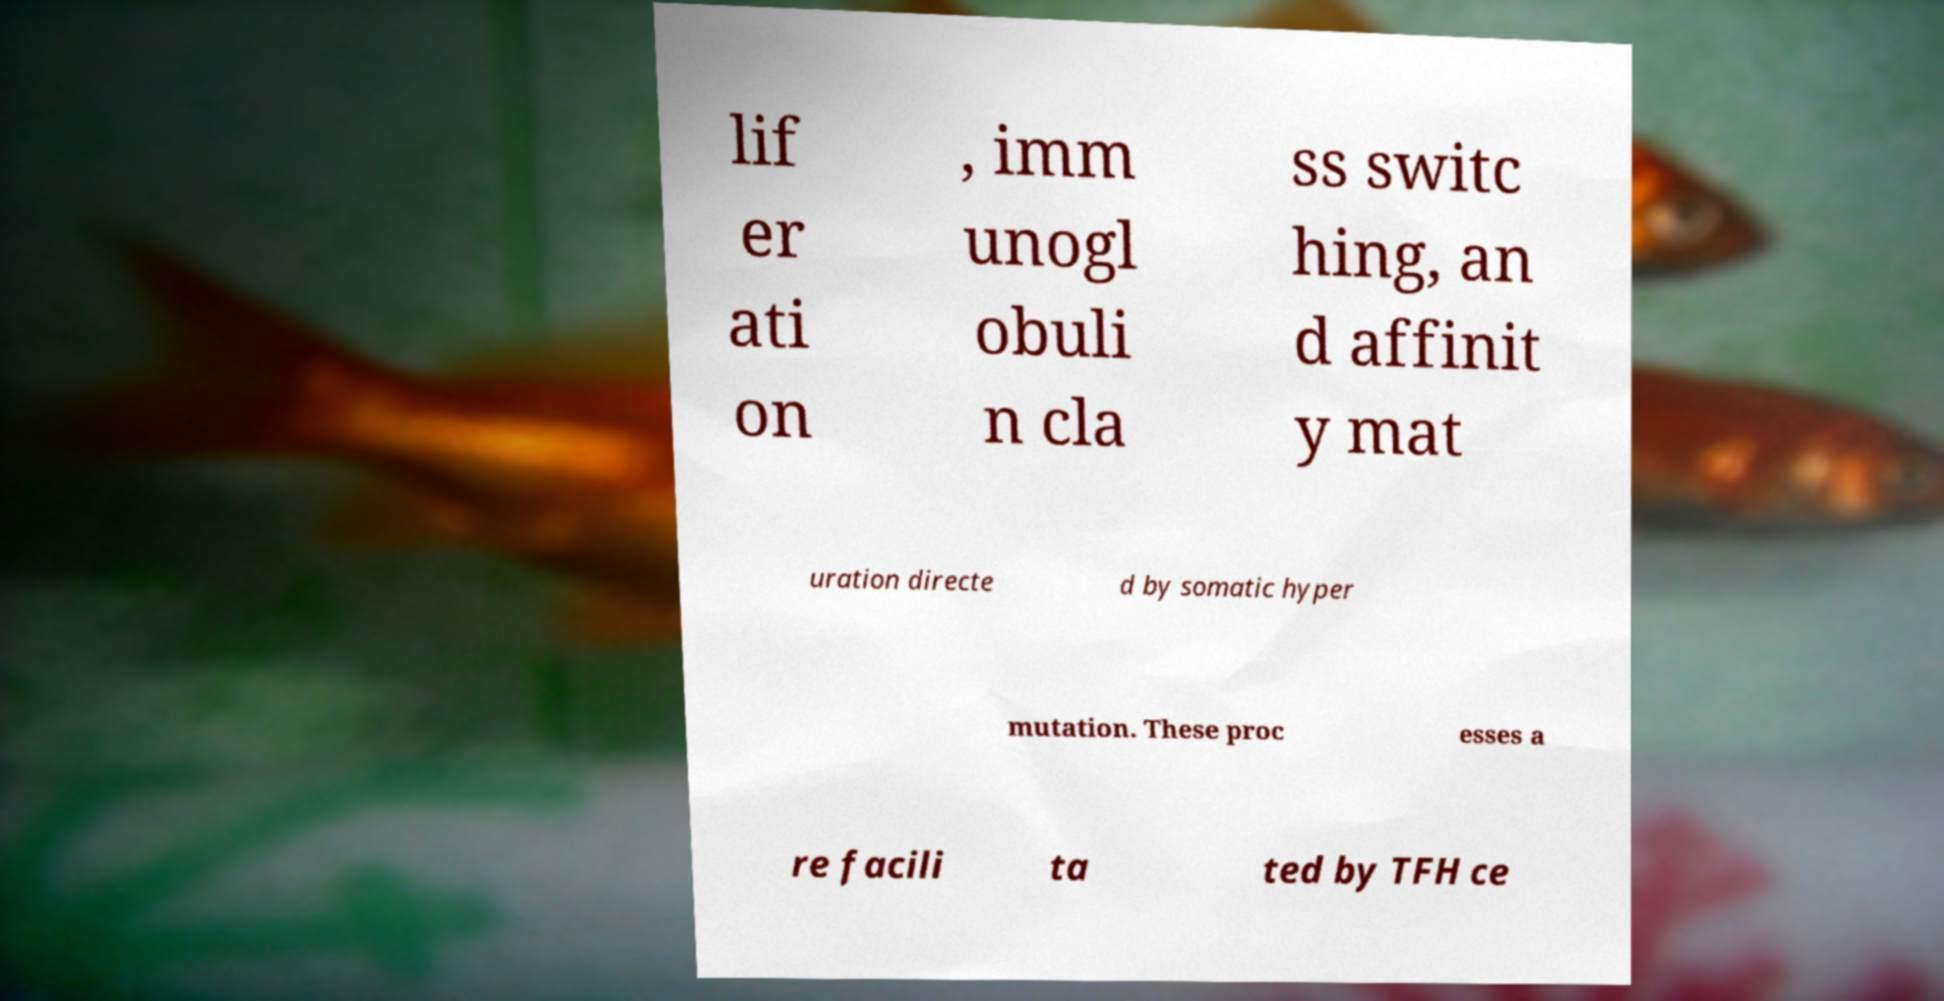Can you accurately transcribe the text from the provided image for me? lif er ati on , imm unogl obuli n cla ss switc hing, an d affinit y mat uration directe d by somatic hyper mutation. These proc esses a re facili ta ted by TFH ce 